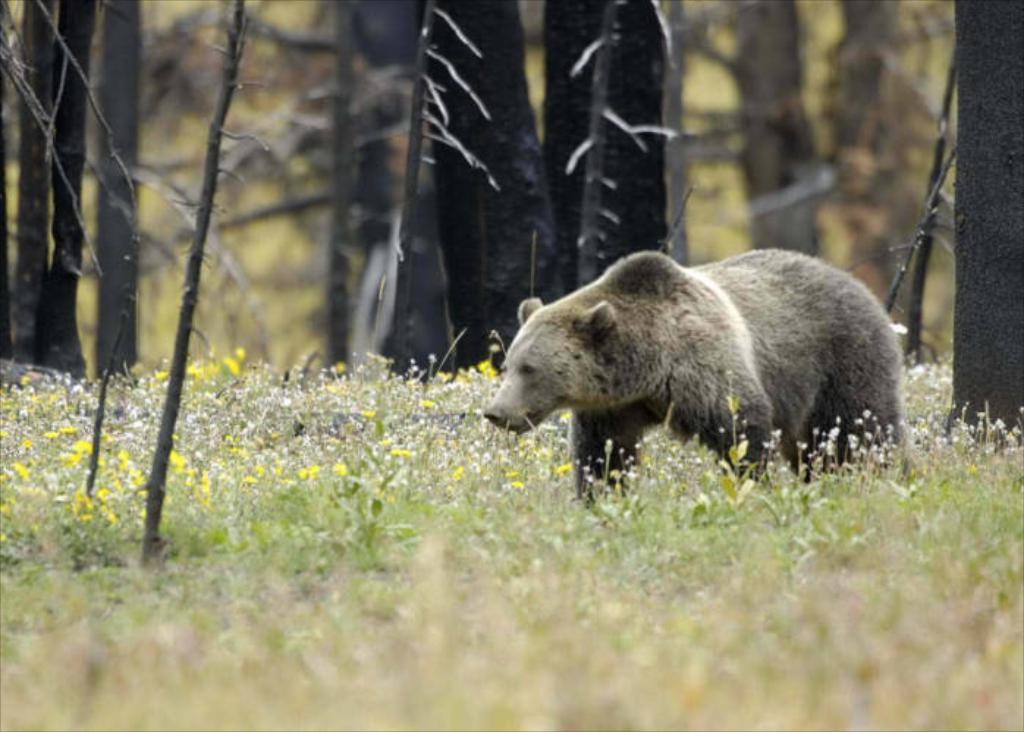What animal is present in the image? There is a bear in the image. What is the bear doing in the image? The bear is walking. What type of terrain surrounds the bear? There is grass around the bear. What other types of vegetation can be seen in the image? There are plants in the image. What can be seen in the background of the image? There is a group of trees in the background of the image. What type of dress is the spy wearing in the image? There is no spy or dress present in the image; it features a bear walking in a grassy area with plants and trees in the background. 